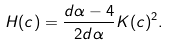Convert formula to latex. <formula><loc_0><loc_0><loc_500><loc_500>H ( c ) = \frac { d \alpha - 4 } { 2 d \alpha } K ( c ) ^ { 2 } .</formula> 